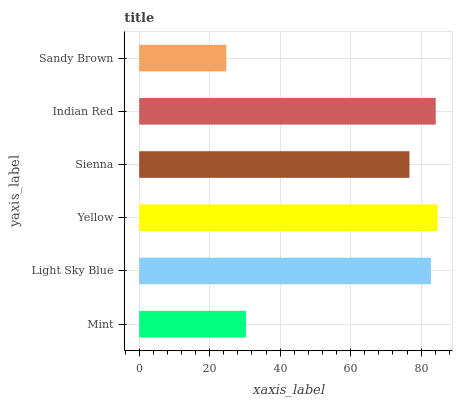Is Sandy Brown the minimum?
Answer yes or no. Yes. Is Yellow the maximum?
Answer yes or no. Yes. Is Light Sky Blue the minimum?
Answer yes or no. No. Is Light Sky Blue the maximum?
Answer yes or no. No. Is Light Sky Blue greater than Mint?
Answer yes or no. Yes. Is Mint less than Light Sky Blue?
Answer yes or no. Yes. Is Mint greater than Light Sky Blue?
Answer yes or no. No. Is Light Sky Blue less than Mint?
Answer yes or no. No. Is Light Sky Blue the high median?
Answer yes or no. Yes. Is Sienna the low median?
Answer yes or no. Yes. Is Mint the high median?
Answer yes or no. No. Is Yellow the low median?
Answer yes or no. No. 